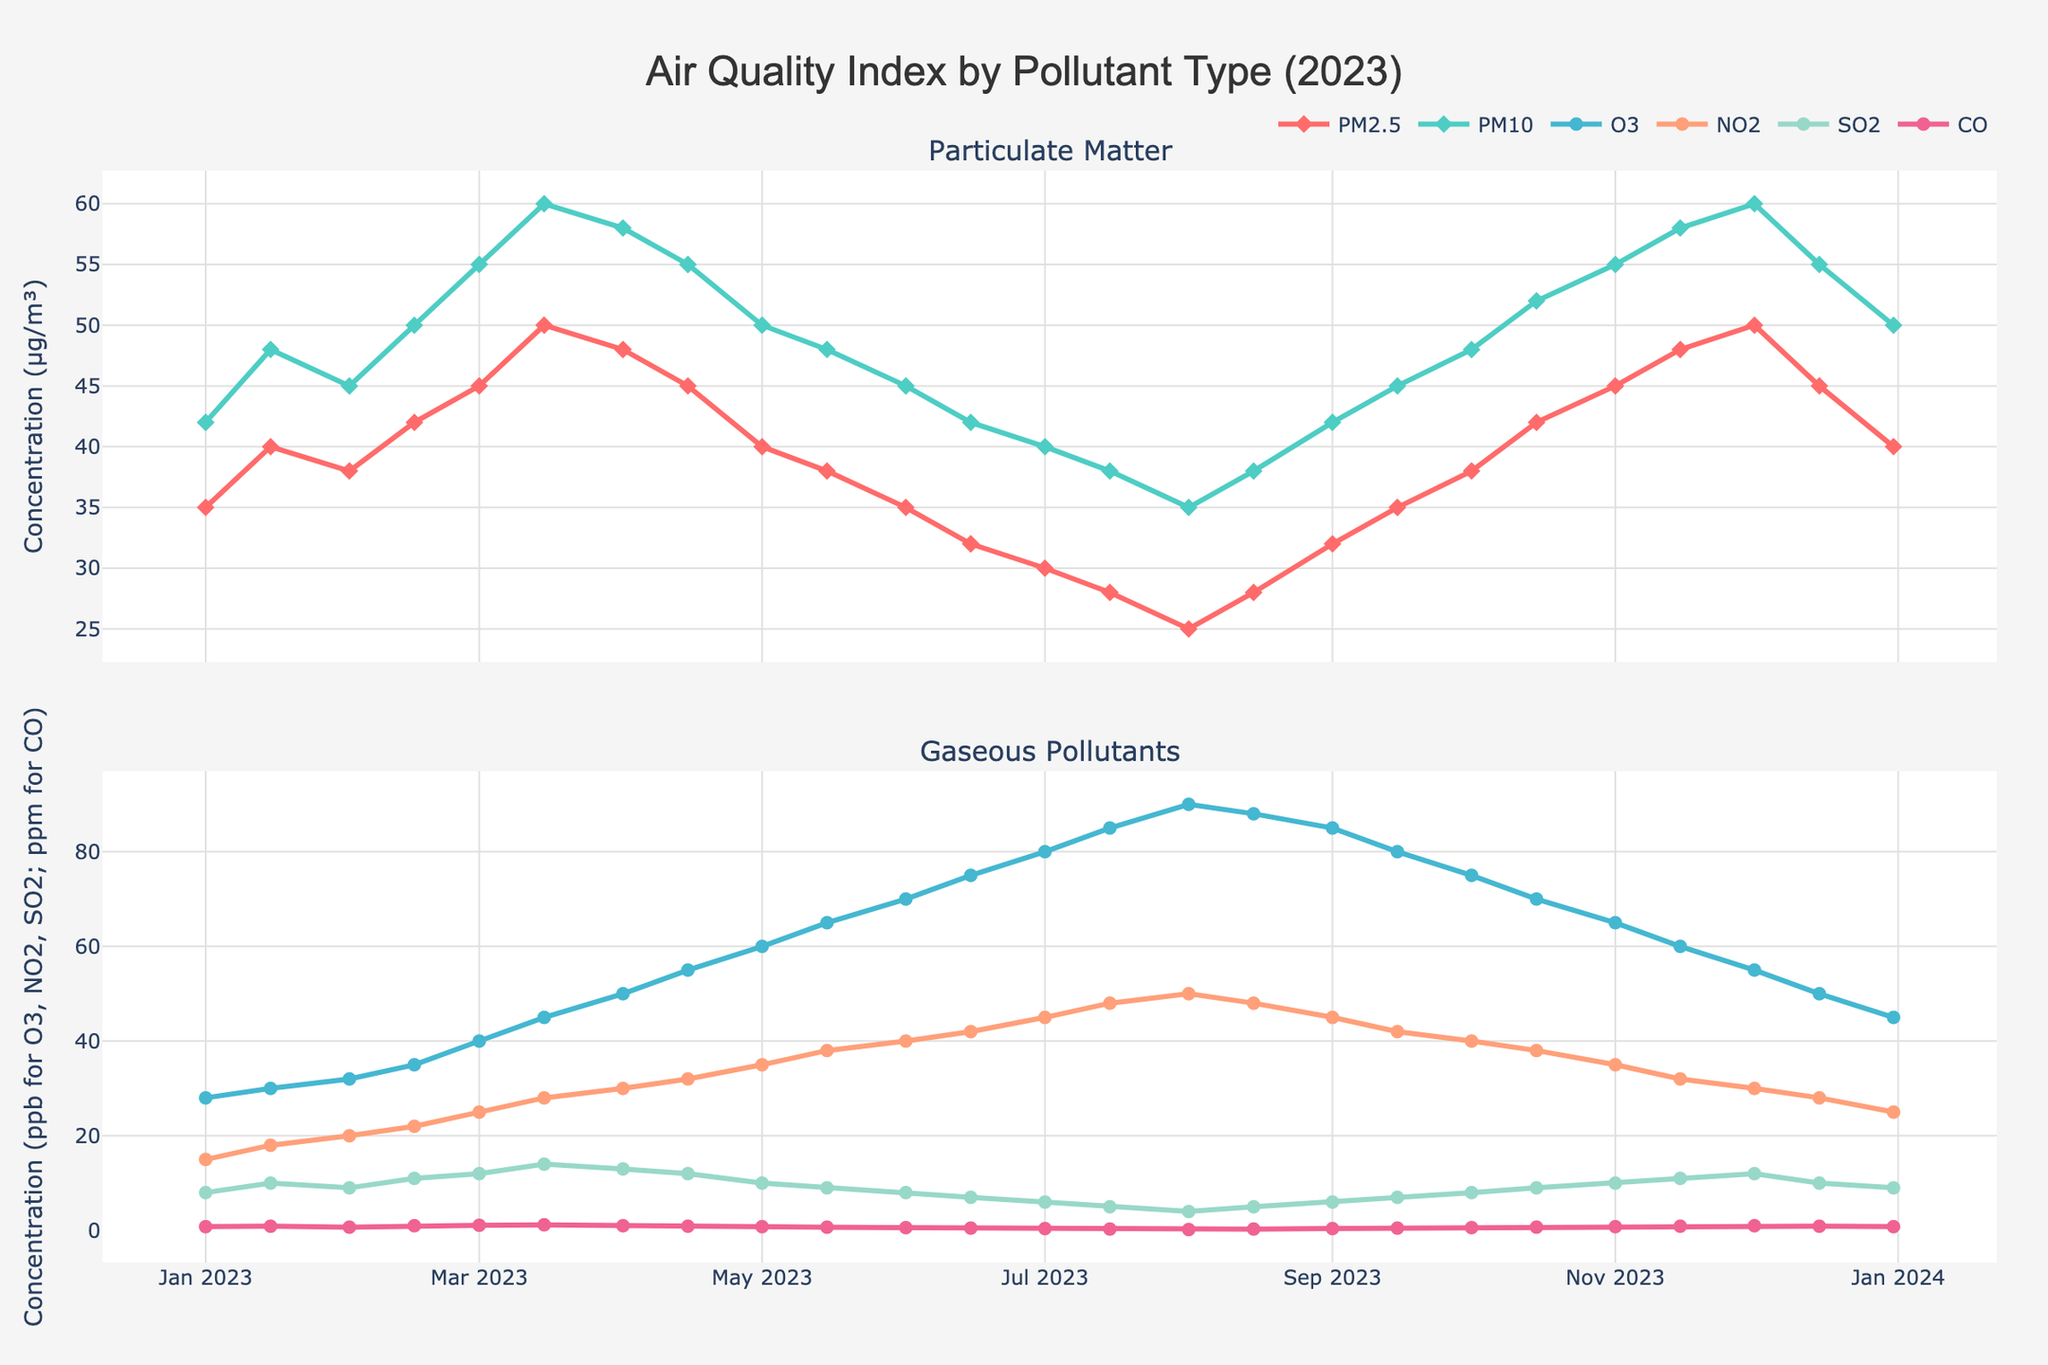what is the overall trend for PM2.5 concentrations over the year? PM2.5 starts at 35 µg/m³ in January, increases and peaks at 50 µg/m³ in April and December, then decreases to 25 µg/m³ in August, finally rising back to 40 µg/m³ by the end of December. This indicates a general increase with two peaks followed by a decrease and final rise.
Answer: General increase with peaks in April and December Which pollutant shows the highest concentration in July? In July, O3 (Ozone) shows the highest concentration compared to other pollutants, reaching 85 ppb. This is evident from the second subplot.
Answer: O3 What is the difference in the concentration of PM10 between January 1st and December 31st? PM10 concentration on January 1st is 42 µg/m³ and on December 31st is 50 µg/m³. The difference is calculated as 50 - 42.
Answer: 8 µg/m³ Which pollutant category shows higher concentrations in general, particulate matters (PM2.5, PM10) or gaseous pollutants (O3, NO2, SO2, CO)? By observing the y-axis scales of both subplots, we can see that particulate matters (PM2.5, PM10) generally have higher concentrations (up to 60 µg/m³) compared to gaseous pollutants (up to 90 ppb for O3 but usually lower for others).
Answer: Particulate matters In which month does SO2 reach its maximum concentration and what is that value? By tracing the SO2 line (the greenish line in the second subplot), its maximum concentration is in March at 14 ppb.
Answer: March, 14 ppb How does the concentration of CO change throughout the year? CO starts at 0.8 ppm in January, peaking slightly at 1.2 ppm in March, then decreases gradually to 0.2 ppm in August, and rises again by the end of the year to 0.9 ppm in December.
Answer: Fluctuates, peaks in March, lowest in August Compare the NO2 concentration in March and September. In March, NO2 concentration is 28 ppb, while in September it is 45 ppb. This shows an increase from March to September.
Answer: Increase What is the average concentration of PM10 for the first quarter of the year (January, February, March)? PM10 concentrations are 42, 48, 45, 50, 55, and 60 µg/m³ in the first quarter. Sum = 300, and average = 300/6.
Answer: 50 µg/m³ 